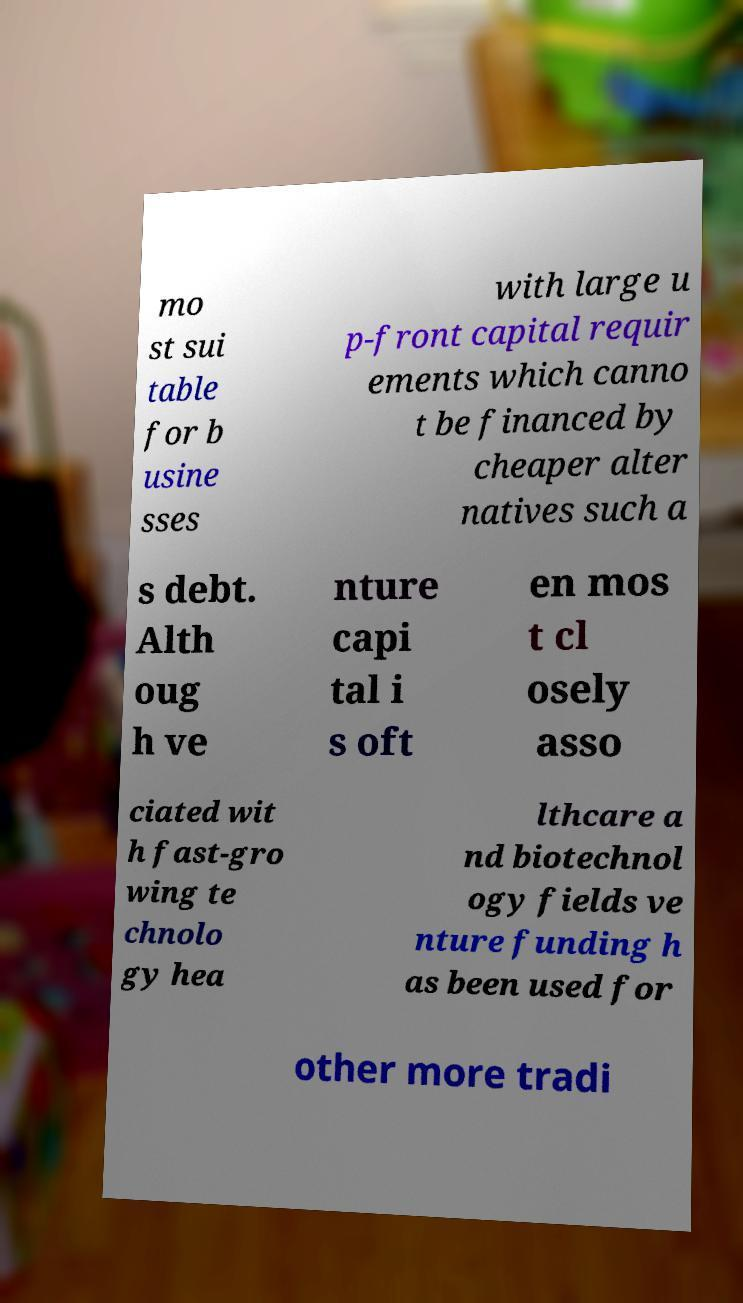Can you accurately transcribe the text from the provided image for me? mo st sui table for b usine sses with large u p-front capital requir ements which canno t be financed by cheaper alter natives such a s debt. Alth oug h ve nture capi tal i s oft en mos t cl osely asso ciated wit h fast-gro wing te chnolo gy hea lthcare a nd biotechnol ogy fields ve nture funding h as been used for other more tradi 